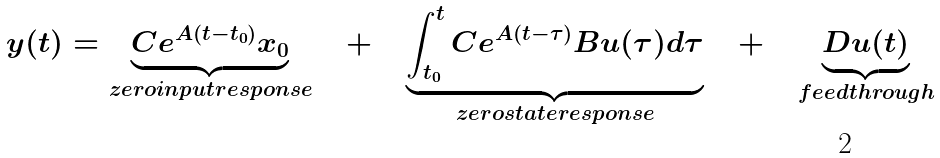<formula> <loc_0><loc_0><loc_500><loc_500>y ( t ) = \underbrace { C e ^ { A ( t - t _ { 0 } ) } x _ { 0 } } _ { z e r o i n p u t r e s p o n s e } \quad + \quad \underbrace { \int _ { t _ { 0 } } ^ { t } C e ^ { A ( t - \tau ) } B u ( \tau ) d \tau } _ { z e r o s t a t e r e s p o n s e } \quad + \quad \underbrace { D u ( t ) } _ { f e e d t h r o u g h }</formula> 